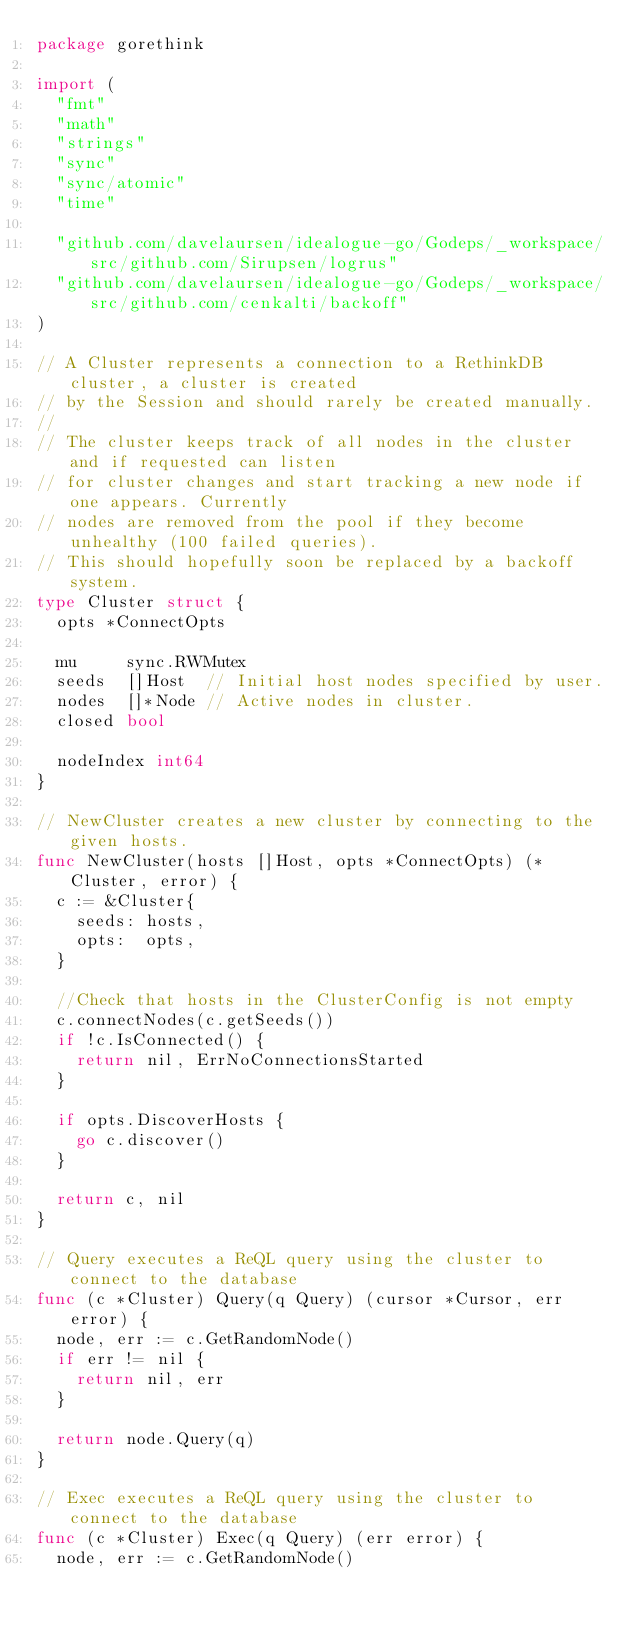Convert code to text. <code><loc_0><loc_0><loc_500><loc_500><_Go_>package gorethink

import (
	"fmt"
	"math"
	"strings"
	"sync"
	"sync/atomic"
	"time"

	"github.com/davelaursen/idealogue-go/Godeps/_workspace/src/github.com/Sirupsen/logrus"
	"github.com/davelaursen/idealogue-go/Godeps/_workspace/src/github.com/cenkalti/backoff"
)

// A Cluster represents a connection to a RethinkDB cluster, a cluster is created
// by the Session and should rarely be created manually.
//
// The cluster keeps track of all nodes in the cluster and if requested can listen
// for cluster changes and start tracking a new node if one appears. Currently
// nodes are removed from the pool if they become unhealthy (100 failed queries).
// This should hopefully soon be replaced by a backoff system.
type Cluster struct {
	opts *ConnectOpts

	mu     sync.RWMutex
	seeds  []Host  // Initial host nodes specified by user.
	nodes  []*Node // Active nodes in cluster.
	closed bool

	nodeIndex int64
}

// NewCluster creates a new cluster by connecting to the given hosts.
func NewCluster(hosts []Host, opts *ConnectOpts) (*Cluster, error) {
	c := &Cluster{
		seeds: hosts,
		opts:  opts,
	}

	//Check that hosts in the ClusterConfig is not empty
	c.connectNodes(c.getSeeds())
	if !c.IsConnected() {
		return nil, ErrNoConnectionsStarted
	}

	if opts.DiscoverHosts {
		go c.discover()
	}

	return c, nil
}

// Query executes a ReQL query using the cluster to connect to the database
func (c *Cluster) Query(q Query) (cursor *Cursor, err error) {
	node, err := c.GetRandomNode()
	if err != nil {
		return nil, err
	}

	return node.Query(q)
}

// Exec executes a ReQL query using the cluster to connect to the database
func (c *Cluster) Exec(q Query) (err error) {
	node, err := c.GetRandomNode()</code> 